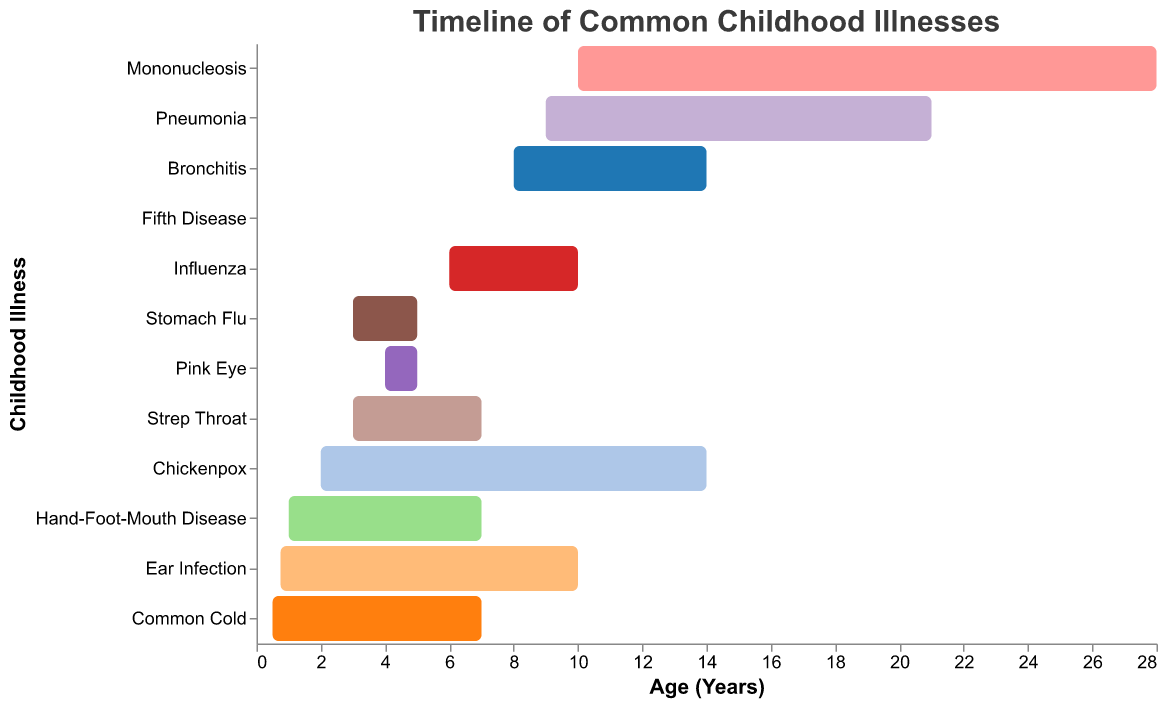What is the title of the figure? The title can be found at the top of the figure.
Answer: Timeline of Common Childhood Illnesses What age does the common cold typically start? Look at the x-axis where the bar for "Common Cold" begins.
Answer: 6 months Which illness has the longest duration? Compare the lengths of all the bars; the longest one represents the illness with the longest duration.
Answer: Mononucleosis Which illnesses start at 2 years of age? Find the bars that begin at 2 years on the x-axis.
Answer: Chickenpox How long does Bronchitis typically last? Look at the tooltip for Bronchitis or measure the length of its bar on the x-axis.
Answer: 14 days Which illness has the shortest duration? Compare the lengths of all the bars; the shortest one represents the illness with the shortest duration.
Answer: Stomach Flu At what age do children typically contract Fifth Disease? Look at the x-axis where the bar for "Fifth Disease" begins.
Answer: 7 years How does the duration of Pneumonia compare to that of Ear Infection? Compare the lengths of the bars for Pneumonia and Ear Infection.
Answer: Pneumonia lasts 11 days longer than Ear Infection What is the average duration of the illnesses listed? Sum up all durations and divide by the total number of illnesses: (7+10+7+14+7+5+3+10+7+14+21+28)/12.
Answer: 11.42 days Which illnesses have a duration of exactly 7 days? Identify the bars whose length on the x-axis measures exactly 7 days.
Answer: Common Cold, Hand-Foot-Mouth Disease, Strep Throat, Fifth Disease 